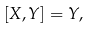Convert formula to latex. <formula><loc_0><loc_0><loc_500><loc_500>[ X , Y ] = Y ,</formula> 